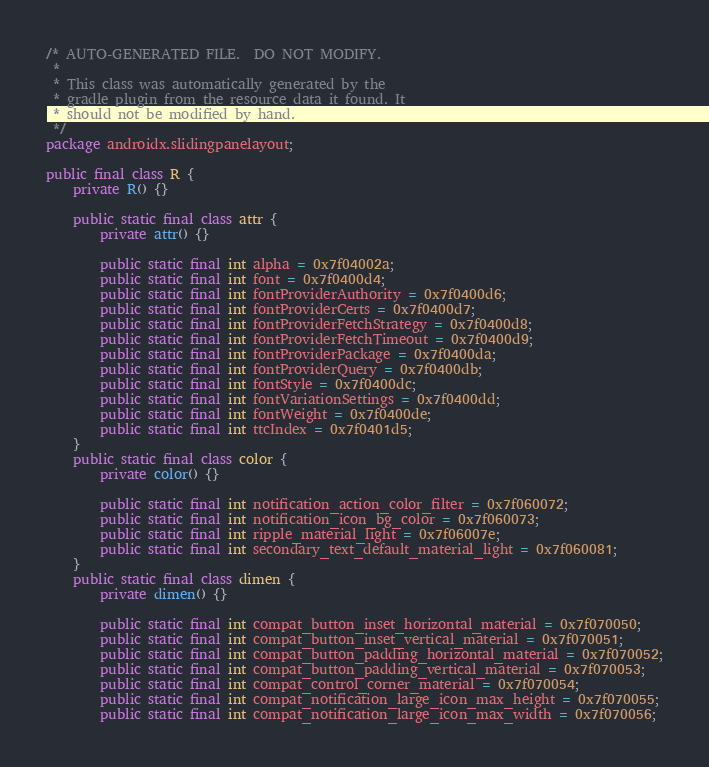Convert code to text. <code><loc_0><loc_0><loc_500><loc_500><_Java_>/* AUTO-GENERATED FILE.  DO NOT MODIFY.
 *
 * This class was automatically generated by the
 * gradle plugin from the resource data it found. It
 * should not be modified by hand.
 */
package androidx.slidingpanelayout;

public final class R {
    private R() {}

    public static final class attr {
        private attr() {}

        public static final int alpha = 0x7f04002a;
        public static final int font = 0x7f0400d4;
        public static final int fontProviderAuthority = 0x7f0400d6;
        public static final int fontProviderCerts = 0x7f0400d7;
        public static final int fontProviderFetchStrategy = 0x7f0400d8;
        public static final int fontProviderFetchTimeout = 0x7f0400d9;
        public static final int fontProviderPackage = 0x7f0400da;
        public static final int fontProviderQuery = 0x7f0400db;
        public static final int fontStyle = 0x7f0400dc;
        public static final int fontVariationSettings = 0x7f0400dd;
        public static final int fontWeight = 0x7f0400de;
        public static final int ttcIndex = 0x7f0401d5;
    }
    public static final class color {
        private color() {}

        public static final int notification_action_color_filter = 0x7f060072;
        public static final int notification_icon_bg_color = 0x7f060073;
        public static final int ripple_material_light = 0x7f06007e;
        public static final int secondary_text_default_material_light = 0x7f060081;
    }
    public static final class dimen {
        private dimen() {}

        public static final int compat_button_inset_horizontal_material = 0x7f070050;
        public static final int compat_button_inset_vertical_material = 0x7f070051;
        public static final int compat_button_padding_horizontal_material = 0x7f070052;
        public static final int compat_button_padding_vertical_material = 0x7f070053;
        public static final int compat_control_corner_material = 0x7f070054;
        public static final int compat_notification_large_icon_max_height = 0x7f070055;
        public static final int compat_notification_large_icon_max_width = 0x7f070056;</code> 